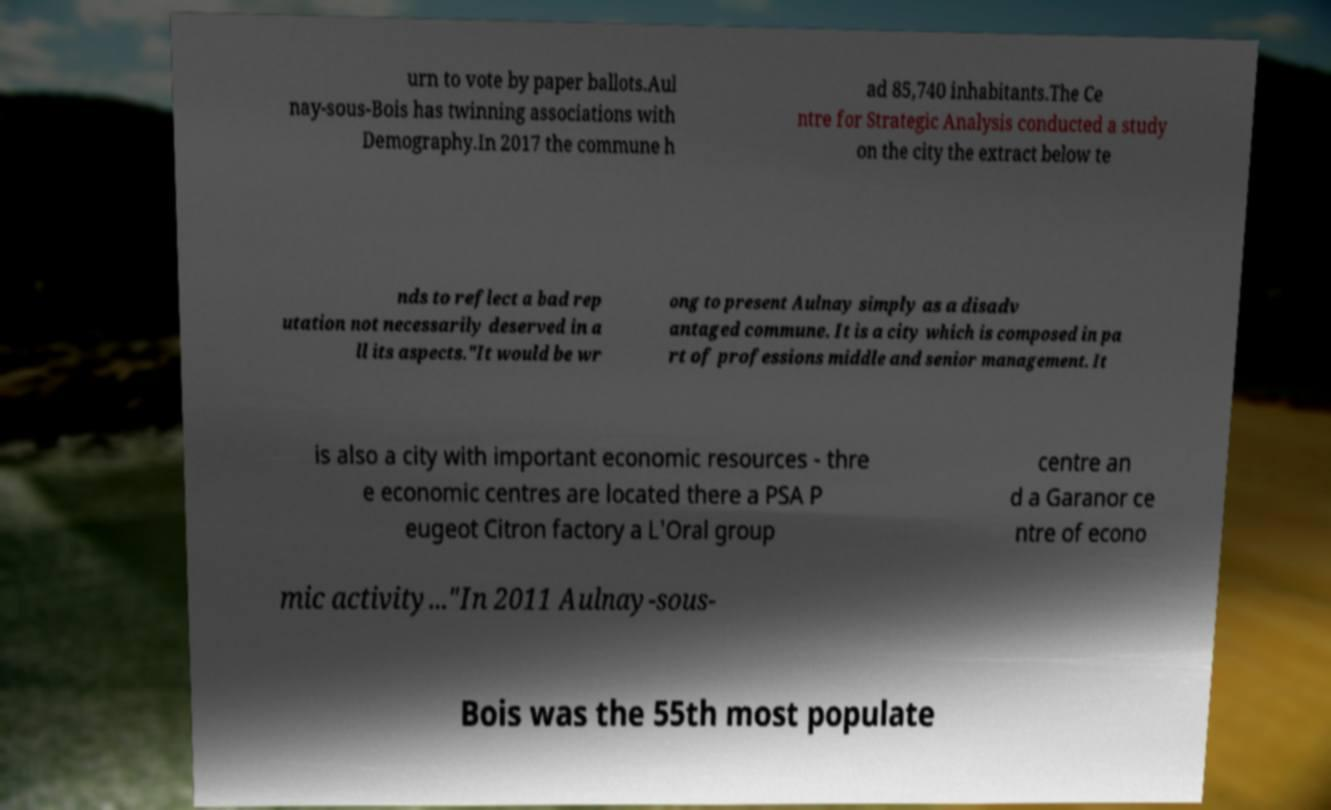Could you extract and type out the text from this image? urn to vote by paper ballots.Aul nay-sous-Bois has twinning associations with Demography.In 2017 the commune h ad 85,740 inhabitants.The Ce ntre for Strategic Analysis conducted a study on the city the extract below te nds to reflect a bad rep utation not necessarily deserved in a ll its aspects."It would be wr ong to present Aulnay simply as a disadv antaged commune. It is a city which is composed in pa rt of professions middle and senior management. It is also a city with important economic resources - thre e economic centres are located there a PSA P eugeot Citron factory a L'Oral group centre an d a Garanor ce ntre of econo mic activity..."In 2011 Aulnay-sous- Bois was the 55th most populate 